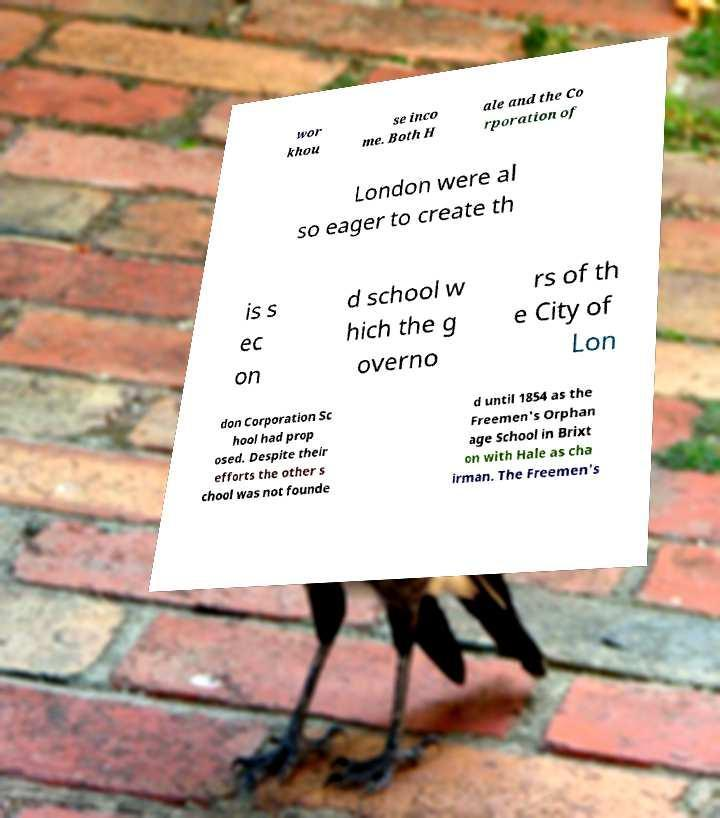I need the written content from this picture converted into text. Can you do that? wor khou se inco me. Both H ale and the Co rporation of London were al so eager to create th is s ec on d school w hich the g overno rs of th e City of Lon don Corporation Sc hool had prop osed. Despite their efforts the other s chool was not founde d until 1854 as the Freemen's Orphan age School in Brixt on with Hale as cha irman. The Freemen's 